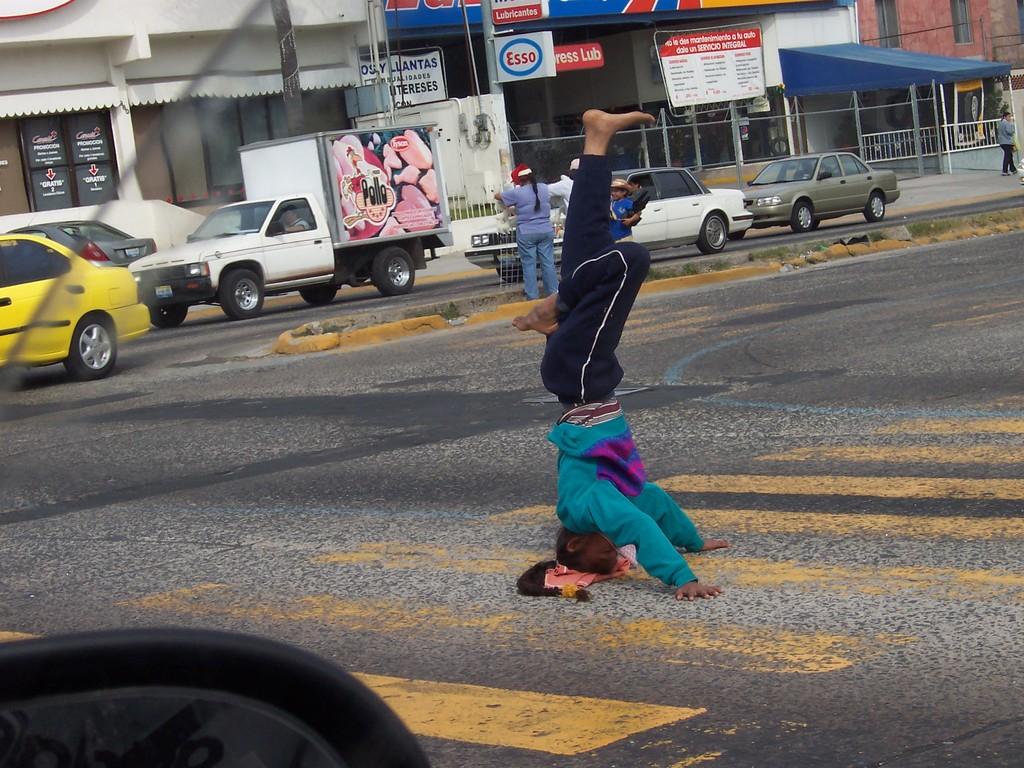What type of gas is sold on the white sign?
Your answer should be very brief. Esso. 